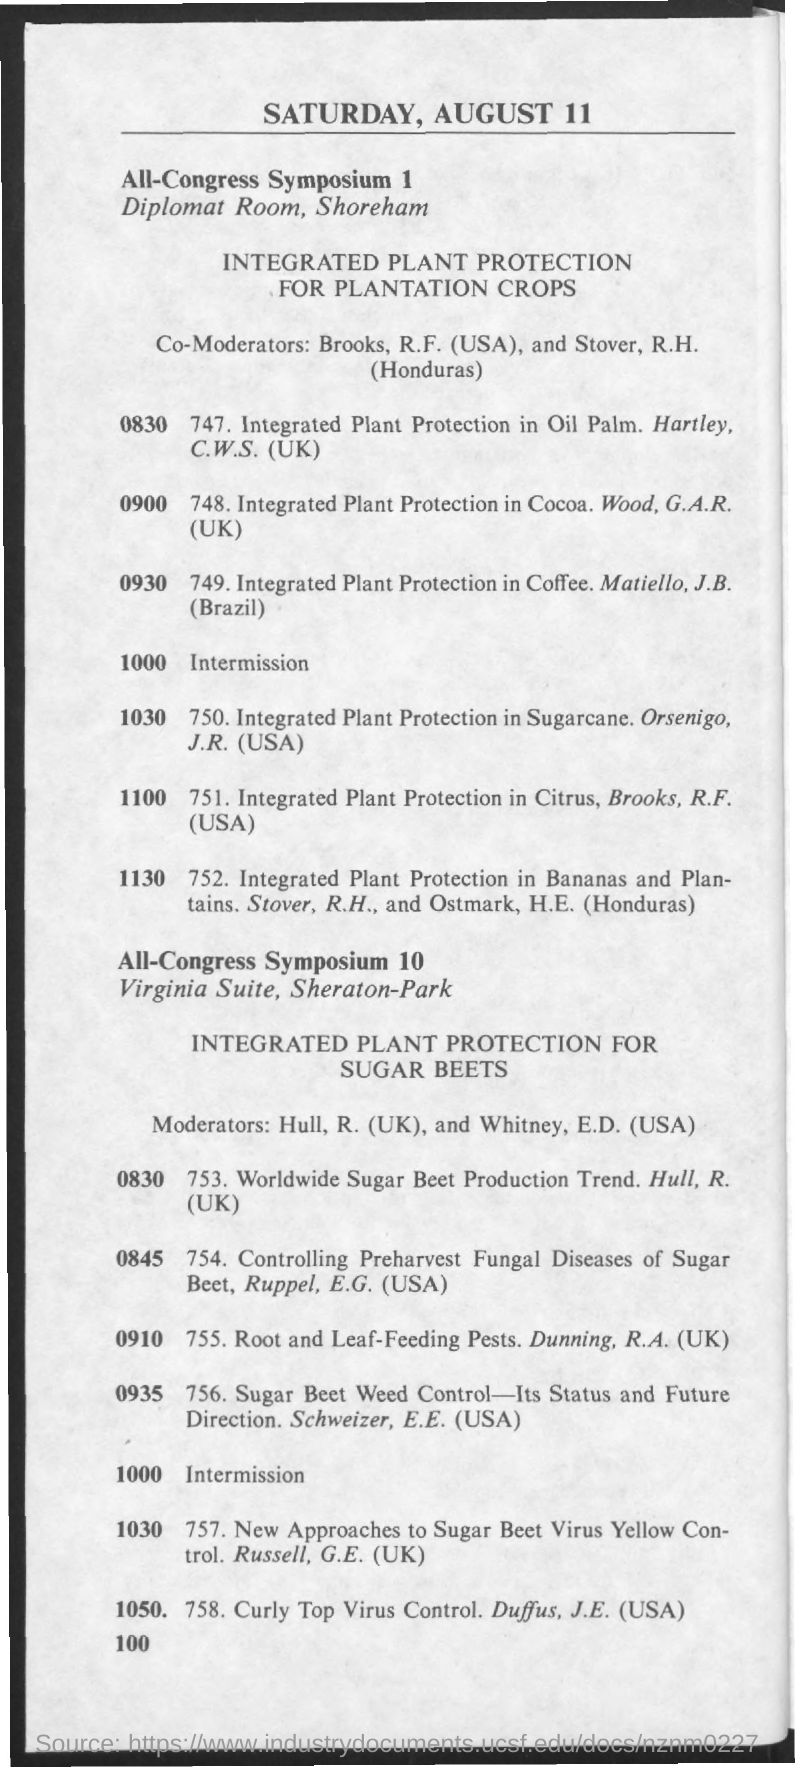What is the date mentioned in the document?
Your answer should be very brief. Saturday, August 11. 